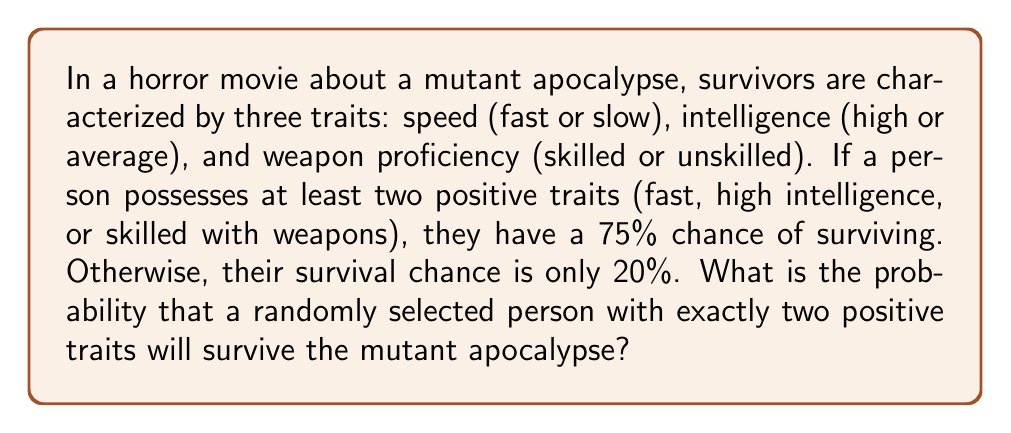What is the answer to this math problem? Let's approach this step-by-step:

1) First, we need to understand what the question is asking. We're looking for the probability of survival for a person with exactly two positive traits.

2) From the given information, we know that a person with at least two positive traits has a 75% chance of survival.

3) In this case, we're dealing with a person who has exactly two positive traits, which falls into the category of "at least two positive traits".

4) Therefore, the probability of survival for this person is 75% or 0.75.

5) To express this as a mathematical equation:

   $$P(\text{survival}|\text{exactly two positive traits}) = 0.75$$

   Where $P(A|B)$ represents the probability of event A given that event B has occurred.

6) It's worth noting that in this scenario, having exactly two positive traits or all three positive traits results in the same survival probability. The critical threshold is having at least two positive traits.

7) If we were to calculate the probability of having exactly two positive traits out of the three possible traits, we would use the combination formula:

   $$\binom{3}{2} = \frac{3!}{2!(3-2)!} = 3$$

   This means there are 3 ways to have exactly two positive traits out of the three traits.

8) However, this calculation isn't necessary to answer the specific question asked, which only requires us to know the survival probability given that the person already has two positive traits.
Answer: $0.75$ or $75\%$ 